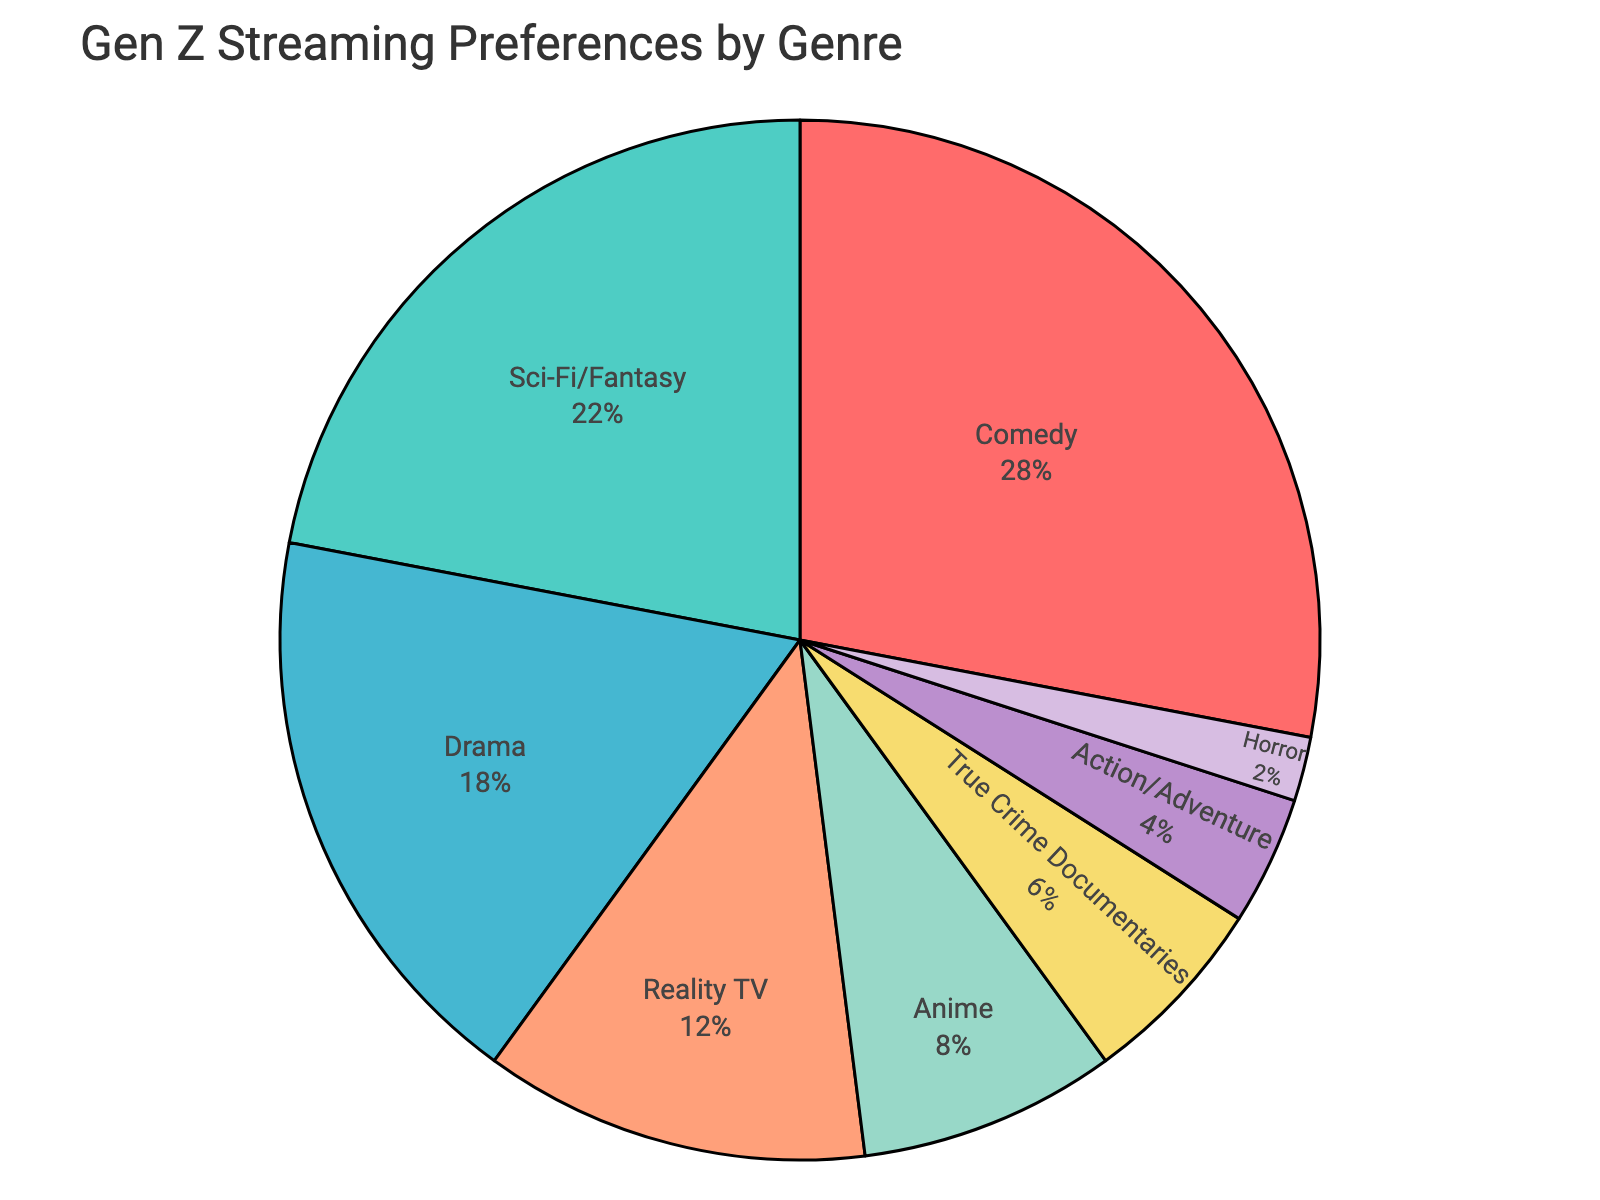What's the most popular genre among Gen Z viewers? The pie chart shows various genres with their corresponding percentages. By identifying the genre with the largest section, we see that Comedy has the highest percentage at 28%.
Answer: Comedy Which genres combined account for more than half of Gen Z's preferences? Adding up the percentages of the largest segments until more than 50% is reached: Comedy (28%) + Sci-Fi/Fantasy (22%) = 50%. These two genres together account for exactly 50%, and adding any additional genre would surpass 50%.
Answer: Comedy and Sci-Fi/Fantasy How much more popular is Comedy compared to Horror? Comedy has a percentage of 28%, and Horror has 2%. The difference between these percentages is 28% - 2% = 26%.
Answer: 26% What percentage of Gen Z viewers prefer genres classified as Fiction (Comedy, Sci-Fi/Fantasy, Drama, and Anime)? Adding the percentages of these fiction genres: Comedy (28%) + Sci-Fi/Fantasy (22%) + Drama (18%) + Anime (8%) = 76%.
Answer: 76% Which genre is least preferred by Gen Z viewers? The smallest section on the pie chart, representing the least preferred genre, is Horror with 2%.
Answer: Horror How does the preference for Drama compare to the preference for Reality TV? Drama accounts for 18% while Reality TV accounts for 12%. Drama is 18% - 12% = 6% more preferred than Reality TV.
Answer: 6% What is the combined preference percentage for niche genres (Anime, True Crime Documentaries, Action/Adventure, Horror)? Adding the percentages of these niche genres: Anime (8%) + True Crime Documentaries (6%) + Action/Adventure (4%) + Horror (2%) = 20%.
Answer: 20% What are the total percentages of Drama and True Crime Documentaries combined? Drama and True Crime Documentaries have percentages of 18% and 6%, respectively. Adding these together: 18% + 6% = 24%.
Answer: 24% Identify two genres whose combined percentages equal the percentage of Drama. Adding the percentages of various genre pairs until 18% is reached: Reality TV (12%) + Action/Adventure (4%) = 16% (which is less), but Anime (8%) + True Crime Documentaries (6%) = 14% (closer), and there are no pairs that exactly equal 18%.
Answer: None What percentage of Gen Z viewers prefers genres other than Comedy? Starting with the total 100% and subtracting the percentage for Comedy: 100% - 28% = 72%.
Answer: 72% 